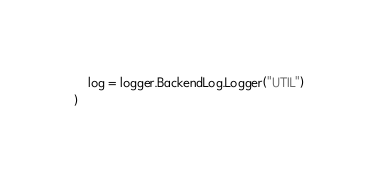Convert code to text. <code><loc_0><loc_0><loc_500><loc_500><_Go_>	log = logger.BackendLog.Logger("UTIL")
)
</code> 